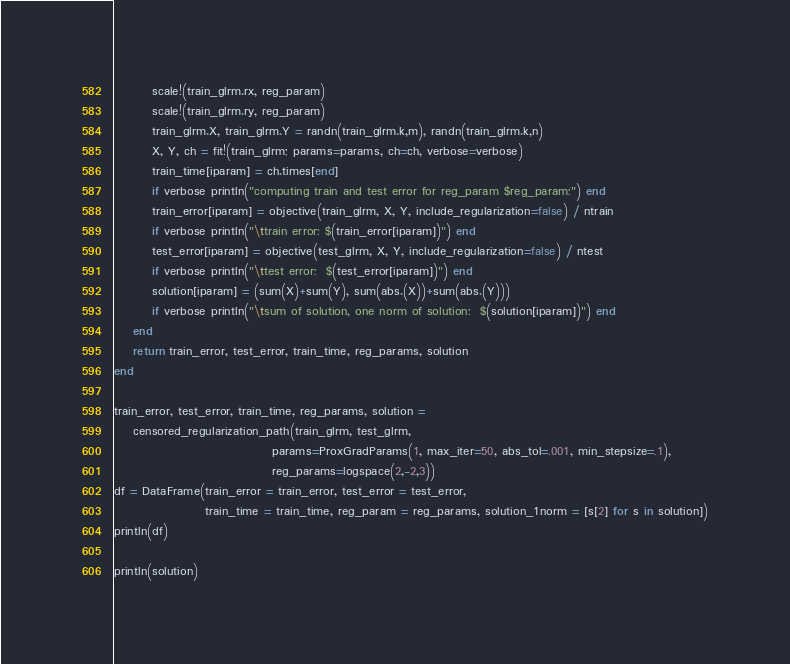<code> <loc_0><loc_0><loc_500><loc_500><_Julia_>        scale!(train_glrm.rx, reg_param)
        scale!(train_glrm.ry, reg_param)
        train_glrm.X, train_glrm.Y = randn(train_glrm.k,m), randn(train_glrm.k,n)
        X, Y, ch = fit!(train_glrm; params=params, ch=ch, verbose=verbose)
        train_time[iparam] = ch.times[end]
        if verbose println("computing train and test error for reg_param $reg_param:") end
        train_error[iparam] = objective(train_glrm, X, Y, include_regularization=false) / ntrain
        if verbose println("\ttrain error: $(train_error[iparam])") end
        test_error[iparam] = objective(test_glrm, X, Y, include_regularization=false) / ntest
        if verbose println("\ttest error:  $(test_error[iparam])") end
        solution[iparam] = (sum(X)+sum(Y), sum(abs.(X))+sum(abs.(Y)))
        if verbose println("\tsum of solution, one norm of solution:  $(solution[iparam])") end
    end
    return train_error, test_error, train_time, reg_params, solution
end

train_error, test_error, train_time, reg_params, solution =
    censored_regularization_path(train_glrm, test_glrm,
                                 params=ProxGradParams(1, max_iter=50, abs_tol=.001, min_stepsize=.1),
                                 reg_params=logspace(2,-2,3))
df = DataFrame(train_error = train_error, test_error = test_error,
                   train_time = train_time, reg_param = reg_params, solution_1norm = [s[2] for s in solution])
println(df)

println(solution)
</code> 